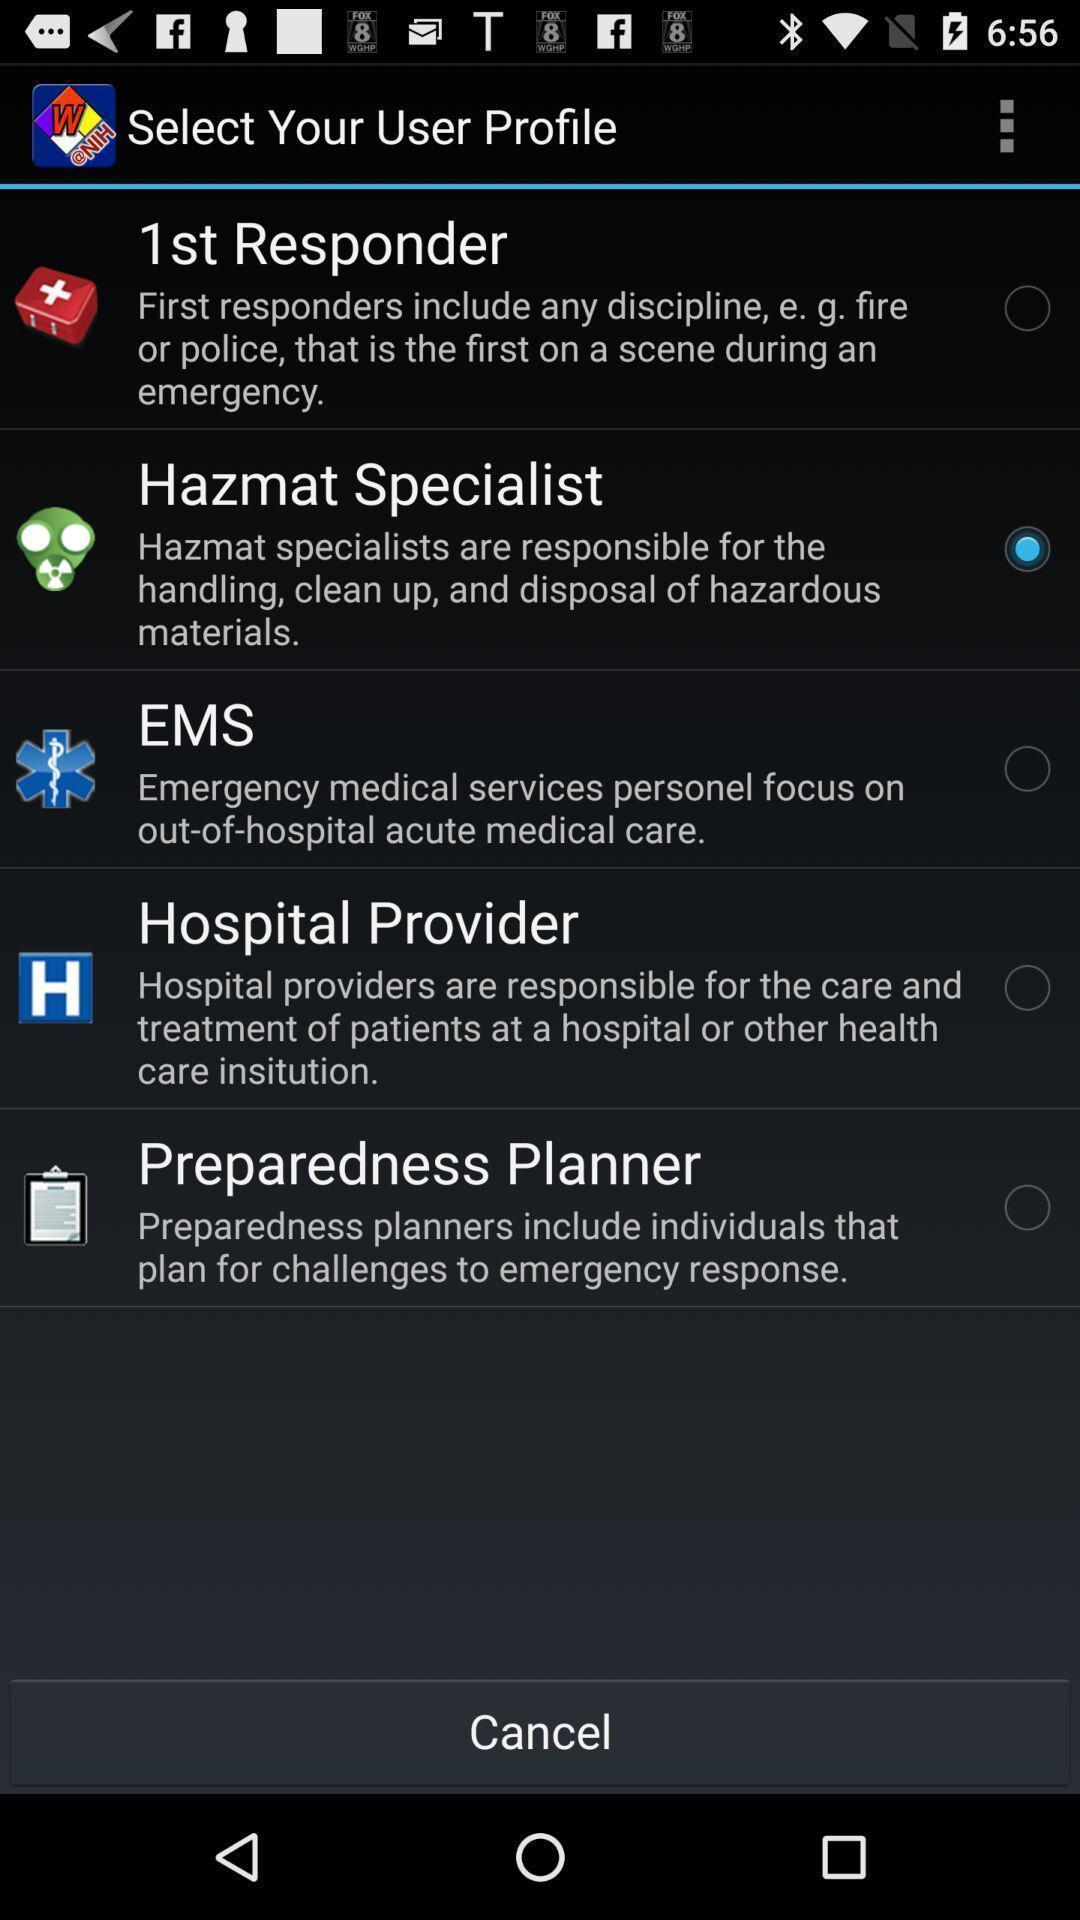Summarize the information in this screenshot. Page showing different options on an app. 